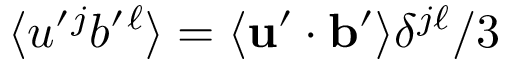Convert formula to latex. <formula><loc_0><loc_0><loc_500><loc_500>\langle { u ^ { \prime ^ { j } b ^ { \prime ^ { \ell } } \rangle = \langle { { u } ^ { \prime } \cdot { b } ^ { \prime } } \rangle \delta ^ { j \ell } / 3</formula> 